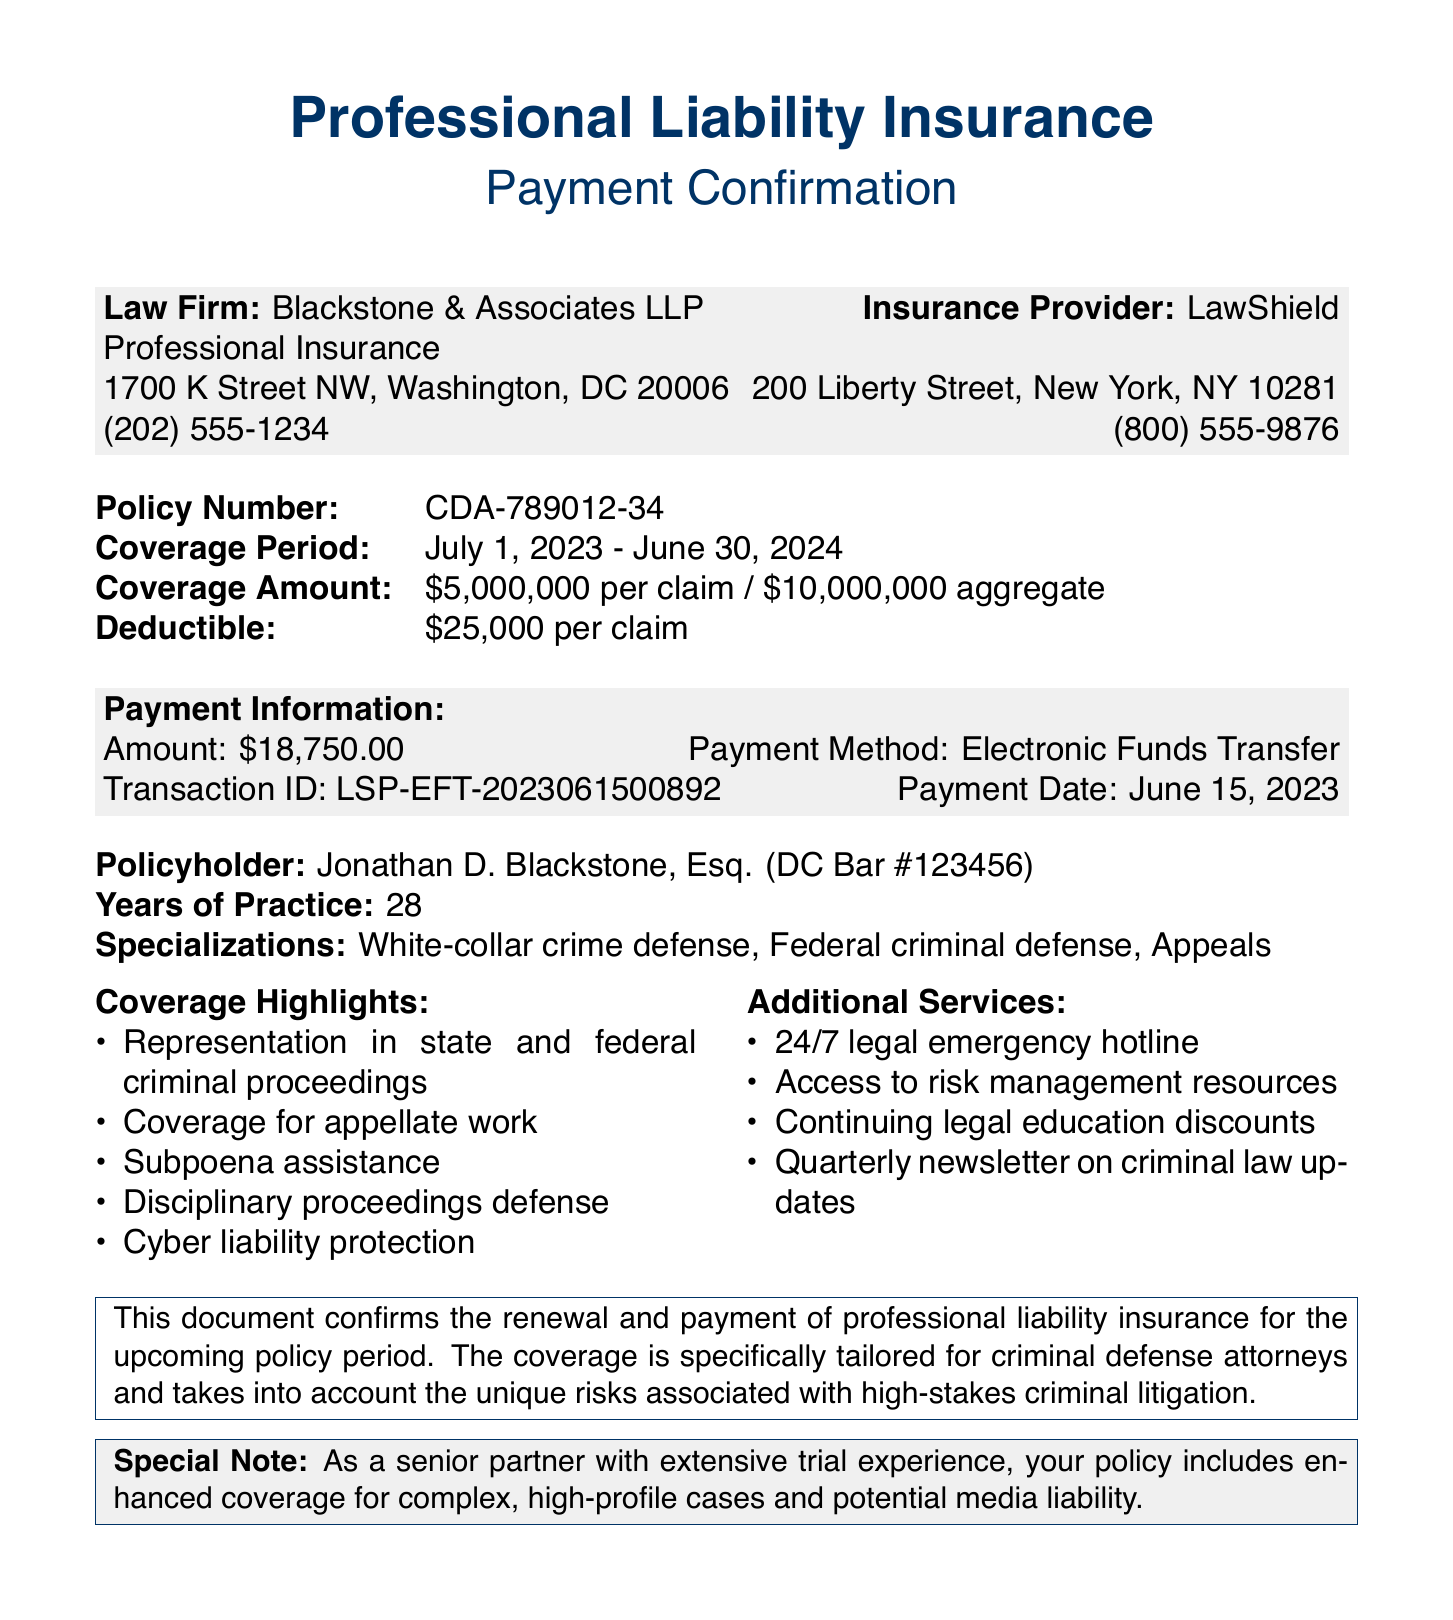what is the policy number? The policy number is explicitly stated in the document, which is CDA-789012-34.
Answer: CDA-789012-34 what is the coverage amount? The coverage amount is detailed in the policy details section as $5,000,000 per claim / $10,000,000 aggregate.
Answer: $5,000,000 per claim / $10,000,000 aggregate when is the coverage period? The coverage period is indicated in the document as July 1, 2023 - June 30, 2024.
Answer: July 1, 2023 - June 30, 2024 what is the payment amount? The payment amount is specified in the payment information section as $18,750.00.
Answer: $18,750.00 what is the transaction ID? The transaction ID is listed in the document under payment information as LSP-EFT-2023061500892.
Answer: LSP-EFT-2023061500892 which law firm is associated with this insurance? The law firm name is prominently mentioned in the document as Blackstone & Associates LLP.
Answer: Blackstone & Associates LLP how many years of practice does the policyholder have? The years of practice for the policyholder are mentioned in the document as 28 years.
Answer: 28 what additional services are offered? The document includes a list of additional services, such as 24/7 legal emergency hotline and access to risk management resources.
Answer: 24/7 legal emergency hotline, access to risk management resources what is the special note regarding coverage? The special note emphasizes enhanced coverage for complex, high-profile cases and potential media liability.
Answer: Enhanced coverage for complex, high-profile cases and potential media liability 